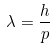<formula> <loc_0><loc_0><loc_500><loc_500>\lambda = { \frac { h } { p } }</formula> 